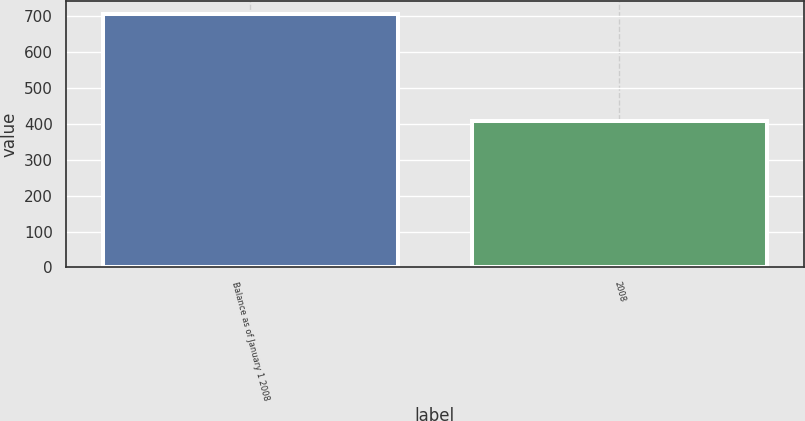<chart> <loc_0><loc_0><loc_500><loc_500><bar_chart><fcel>Balance as of January 1 2008<fcel>2008<nl><fcel>706<fcel>408<nl></chart> 